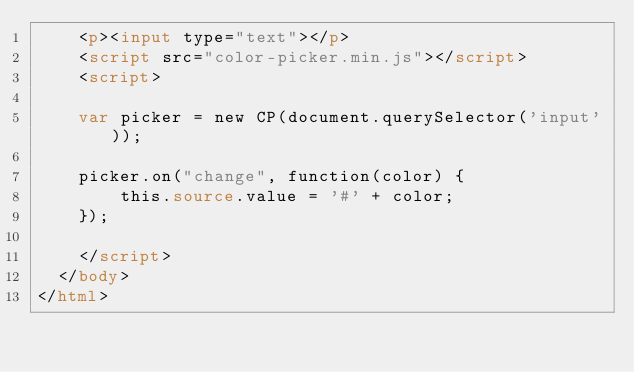<code> <loc_0><loc_0><loc_500><loc_500><_HTML_>    <p><input type="text"></p>
    <script src="color-picker.min.js"></script>
    <script>

    var picker = new CP(document.querySelector('input'));

    picker.on("change", function(color) {
        this.source.value = '#' + color;
    });

    </script>
  </body>
</html></code> 